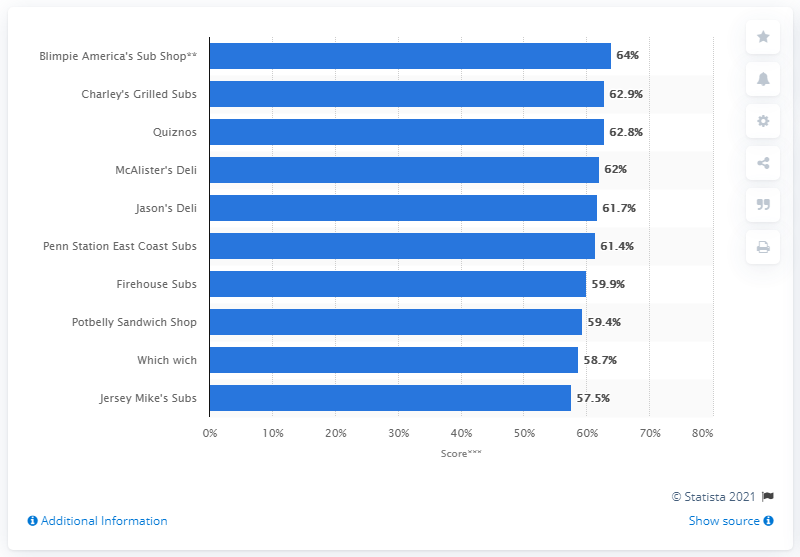Give some essential details in this illustration. Jason's Dell and Which Wich are both fast food chains, but they have distinct differences in their menu offerings, pricing, and overall concept. Jason's Deli offers a variety of salads, sandwiches, soups, and entrees, while Which Wich prides itself on its sandwiches and unique ordering process. Jason's Deli is a sit-down restaurant, while Which Wich is a fast-casual concept. Overall, both chains offer a unique experience, but cater to different customers with varying preferences. There are three restaurants that have a value above 62%. According to the results, Charley's Grilled Subs ranked as the second best sandwich restaurant within the sandwich segment. 